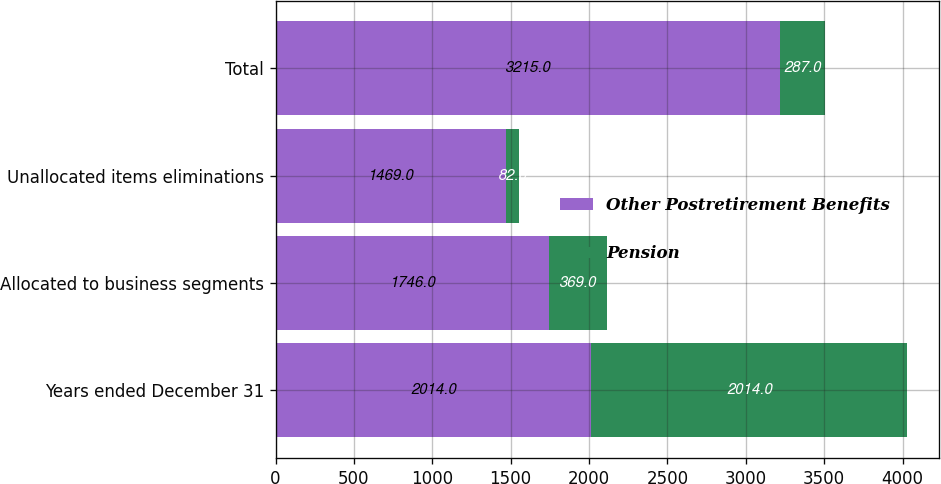Convert chart to OTSL. <chart><loc_0><loc_0><loc_500><loc_500><stacked_bar_chart><ecel><fcel>Years ended December 31<fcel>Allocated to business segments<fcel>Unallocated items eliminations<fcel>Total<nl><fcel>Other Postretirement Benefits<fcel>2014<fcel>1746<fcel>1469<fcel>3215<nl><fcel>Pension<fcel>2014<fcel>369<fcel>82<fcel>287<nl></chart> 